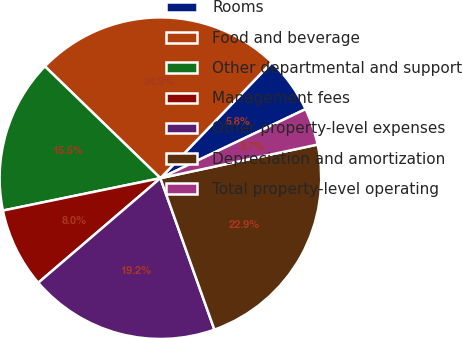Convert chart. <chart><loc_0><loc_0><loc_500><loc_500><pie_chart><fcel>Rooms<fcel>Food and beverage<fcel>Other departmental and support<fcel>Management fees<fcel>Other property-level expenses<fcel>Depreciation and amortization<fcel>Total property-level operating<nl><fcel>5.75%<fcel>24.94%<fcel>15.47%<fcel>8.04%<fcel>19.18%<fcel>22.9%<fcel>3.71%<nl></chart> 